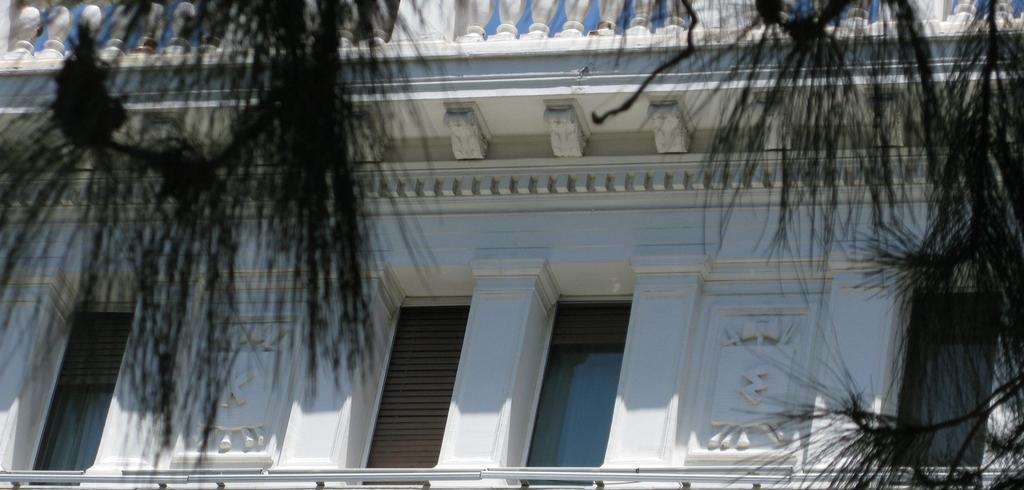What is located on top of the picture in the image? There are plants on top of the picture. What type of objects can be seen in the image that are made of glass? There are glass objects visible in the image. What type of objects can be seen in the image that are made of wood? There are wooden objects visible in the image. What architectural features can be seen in the image? There are pillars visible in the image. What type of decorative elements can be seen in the image? There are carvings visible in the image. What other objects can be seen in the image on a building? There are other objects visible in the image on a building. What time is indicated by the hour on the clock tower in the image? There is no clock tower or hour visible in the image; it features plants, glass objects, wooden objects, pillars, carvings, and other objects on a building. What type of container is used to carry water in the image? There is no container for carrying water, such as a bucket, present in the image. 